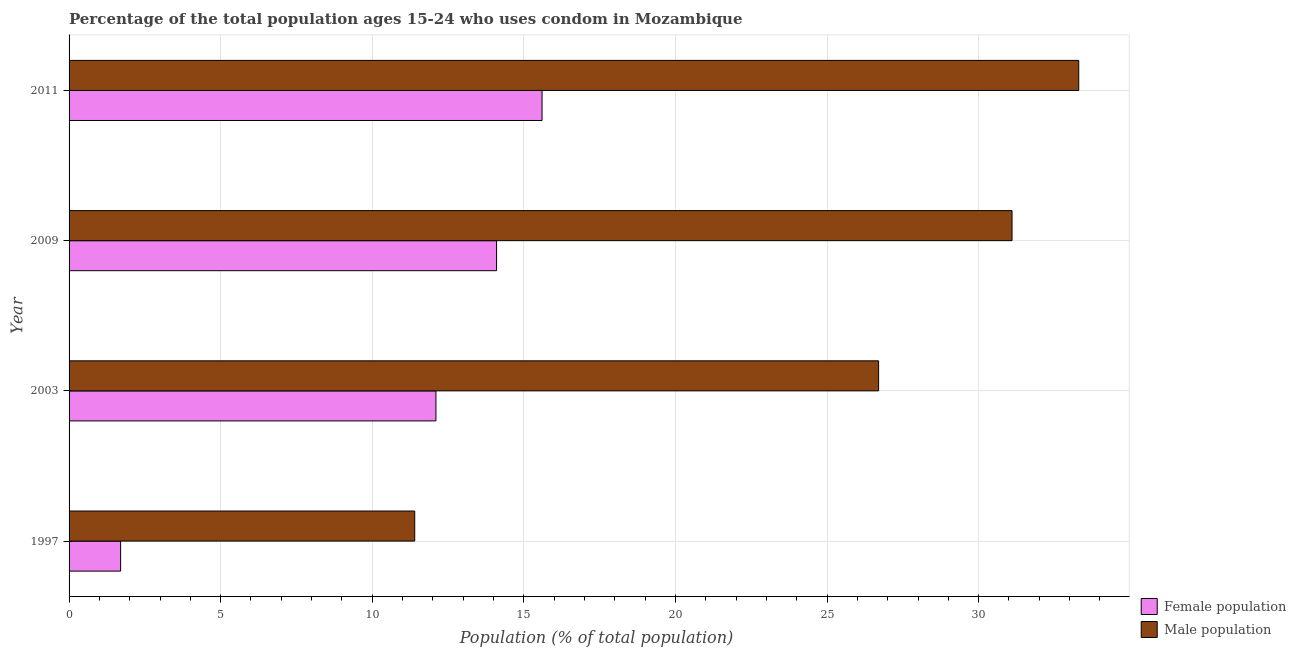Are the number of bars per tick equal to the number of legend labels?
Give a very brief answer. Yes. What is the label of the 4th group of bars from the top?
Your response must be concise. 1997. In how many cases, is the number of bars for a given year not equal to the number of legend labels?
Provide a succinct answer. 0. What is the female population in 1997?
Your answer should be compact. 1.7. Across all years, what is the maximum male population?
Make the answer very short. 33.3. Across all years, what is the minimum female population?
Offer a terse response. 1.7. In which year was the male population maximum?
Your response must be concise. 2011. What is the total male population in the graph?
Provide a short and direct response. 102.5. What is the difference between the male population in 1997 and the female population in 2011?
Your response must be concise. -4.2. What is the average female population per year?
Keep it short and to the point. 10.88. In the year 2003, what is the difference between the male population and female population?
Ensure brevity in your answer.  14.6. What is the ratio of the male population in 2009 to that in 2011?
Provide a succinct answer. 0.93. Is the difference between the female population in 1997 and 2009 greater than the difference between the male population in 1997 and 2009?
Your response must be concise. Yes. What is the difference between the highest and the second highest female population?
Give a very brief answer. 1.5. What is the difference between the highest and the lowest male population?
Provide a short and direct response. 21.9. What does the 1st bar from the top in 2009 represents?
Make the answer very short. Male population. What does the 2nd bar from the bottom in 2009 represents?
Provide a succinct answer. Male population. Are all the bars in the graph horizontal?
Give a very brief answer. Yes. How many years are there in the graph?
Ensure brevity in your answer.  4. Are the values on the major ticks of X-axis written in scientific E-notation?
Keep it short and to the point. No. Does the graph contain any zero values?
Ensure brevity in your answer.  No. What is the title of the graph?
Make the answer very short. Percentage of the total population ages 15-24 who uses condom in Mozambique. What is the label or title of the X-axis?
Offer a terse response. Population (% of total population) . What is the label or title of the Y-axis?
Offer a terse response. Year. What is the Population (% of total population)  of Male population in 1997?
Your response must be concise. 11.4. What is the Population (% of total population)  in Female population in 2003?
Provide a short and direct response. 12.1. What is the Population (% of total population)  in Male population in 2003?
Offer a very short reply. 26.7. What is the Population (% of total population)  of Male population in 2009?
Provide a succinct answer. 31.1. What is the Population (% of total population)  of Female population in 2011?
Provide a short and direct response. 15.6. What is the Population (% of total population)  of Male population in 2011?
Your answer should be very brief. 33.3. Across all years, what is the maximum Population (% of total population)  in Male population?
Make the answer very short. 33.3. Across all years, what is the minimum Population (% of total population)  in Female population?
Your response must be concise. 1.7. What is the total Population (% of total population)  in Female population in the graph?
Your answer should be compact. 43.5. What is the total Population (% of total population)  in Male population in the graph?
Offer a very short reply. 102.5. What is the difference between the Population (% of total population)  in Female population in 1997 and that in 2003?
Keep it short and to the point. -10.4. What is the difference between the Population (% of total population)  of Male population in 1997 and that in 2003?
Your response must be concise. -15.3. What is the difference between the Population (% of total population)  of Male population in 1997 and that in 2009?
Your response must be concise. -19.7. What is the difference between the Population (% of total population)  in Female population in 1997 and that in 2011?
Offer a very short reply. -13.9. What is the difference between the Population (% of total population)  in Male population in 1997 and that in 2011?
Keep it short and to the point. -21.9. What is the difference between the Population (% of total population)  of Female population in 2003 and that in 2009?
Provide a succinct answer. -2. What is the difference between the Population (% of total population)  of Male population in 2003 and that in 2009?
Offer a terse response. -4.4. What is the difference between the Population (% of total population)  in Male population in 2009 and that in 2011?
Provide a succinct answer. -2.2. What is the difference between the Population (% of total population)  in Female population in 1997 and the Population (% of total population)  in Male population in 2003?
Provide a short and direct response. -25. What is the difference between the Population (% of total population)  of Female population in 1997 and the Population (% of total population)  of Male population in 2009?
Ensure brevity in your answer.  -29.4. What is the difference between the Population (% of total population)  of Female population in 1997 and the Population (% of total population)  of Male population in 2011?
Keep it short and to the point. -31.6. What is the difference between the Population (% of total population)  of Female population in 2003 and the Population (% of total population)  of Male population in 2009?
Offer a terse response. -19. What is the difference between the Population (% of total population)  of Female population in 2003 and the Population (% of total population)  of Male population in 2011?
Your answer should be compact. -21.2. What is the difference between the Population (% of total population)  in Female population in 2009 and the Population (% of total population)  in Male population in 2011?
Offer a terse response. -19.2. What is the average Population (% of total population)  of Female population per year?
Offer a terse response. 10.88. What is the average Population (% of total population)  in Male population per year?
Give a very brief answer. 25.62. In the year 2003, what is the difference between the Population (% of total population)  of Female population and Population (% of total population)  of Male population?
Provide a succinct answer. -14.6. In the year 2011, what is the difference between the Population (% of total population)  of Female population and Population (% of total population)  of Male population?
Give a very brief answer. -17.7. What is the ratio of the Population (% of total population)  of Female population in 1997 to that in 2003?
Provide a short and direct response. 0.14. What is the ratio of the Population (% of total population)  in Male population in 1997 to that in 2003?
Your answer should be compact. 0.43. What is the ratio of the Population (% of total population)  of Female population in 1997 to that in 2009?
Your answer should be very brief. 0.12. What is the ratio of the Population (% of total population)  in Male population in 1997 to that in 2009?
Your answer should be compact. 0.37. What is the ratio of the Population (% of total population)  of Female population in 1997 to that in 2011?
Offer a very short reply. 0.11. What is the ratio of the Population (% of total population)  of Male population in 1997 to that in 2011?
Offer a terse response. 0.34. What is the ratio of the Population (% of total population)  of Female population in 2003 to that in 2009?
Offer a very short reply. 0.86. What is the ratio of the Population (% of total population)  in Male population in 2003 to that in 2009?
Give a very brief answer. 0.86. What is the ratio of the Population (% of total population)  in Female population in 2003 to that in 2011?
Offer a terse response. 0.78. What is the ratio of the Population (% of total population)  in Male population in 2003 to that in 2011?
Your answer should be very brief. 0.8. What is the ratio of the Population (% of total population)  of Female population in 2009 to that in 2011?
Ensure brevity in your answer.  0.9. What is the ratio of the Population (% of total population)  of Male population in 2009 to that in 2011?
Ensure brevity in your answer.  0.93. What is the difference between the highest and the lowest Population (% of total population)  of Female population?
Your answer should be very brief. 13.9. What is the difference between the highest and the lowest Population (% of total population)  in Male population?
Ensure brevity in your answer.  21.9. 